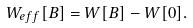Convert formula to latex. <formula><loc_0><loc_0><loc_500><loc_500>W _ { e f f } [ B ] = W [ B ] - W [ 0 ] .</formula> 